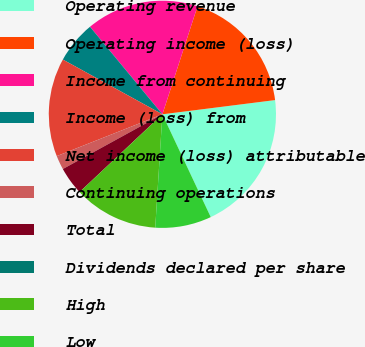Convert chart. <chart><loc_0><loc_0><loc_500><loc_500><pie_chart><fcel>Operating revenue<fcel>Operating income (loss)<fcel>Income from continuing<fcel>Income (loss) from<fcel>Net income (loss) attributable<fcel>Continuing operations<fcel>Total<fcel>Dividends declared per share<fcel>High<fcel>Low<nl><fcel>20.0%<fcel>18.0%<fcel>16.0%<fcel>6.0%<fcel>14.0%<fcel>2.0%<fcel>4.0%<fcel>0.0%<fcel>12.0%<fcel>8.0%<nl></chart> 